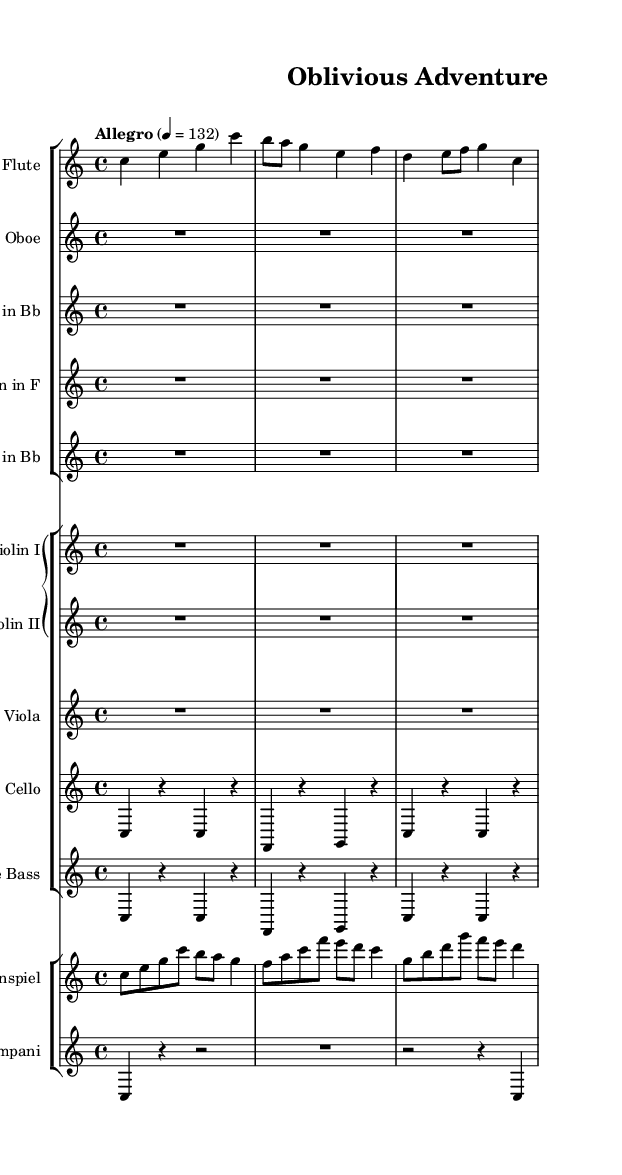What is the key signature of this music? The key signature is C major, which has no sharps or flats.
Answer: C major What is the time signature of this score? The time signature is indicated at the beginning of the sheet music with a 4 over 4, meaning there are four beats in each measure.
Answer: 4/4 What is the tempo marking indicated in the score? The tempo marking states "Allegro" with a metronome marking of 132, indicating a fast tempo that is lively.
Answer: Allegro 132 Which instruments are playing in unison during the introduction? The flutes, oboes, clarinets, horns, and trumpets are indicated to be playing together, which you can tell from their entries in the same measure without separate parts in the first part of the score.
Answer: Flute, Oboe, Clarinet, Horn, Trumpet How many measures are in the cello part based on the provided music? By counting the measures indicated in the cello part, it appears there are nine distinct measures noted, which includes rests and active notes.
Answer: Nine What type of music is this score representing? This score represents an upbeat orchestral score typical of family-friendly adventure movies, characterized by lively melodies and a joyful feel.
Answer: Upbeat orchestral score 